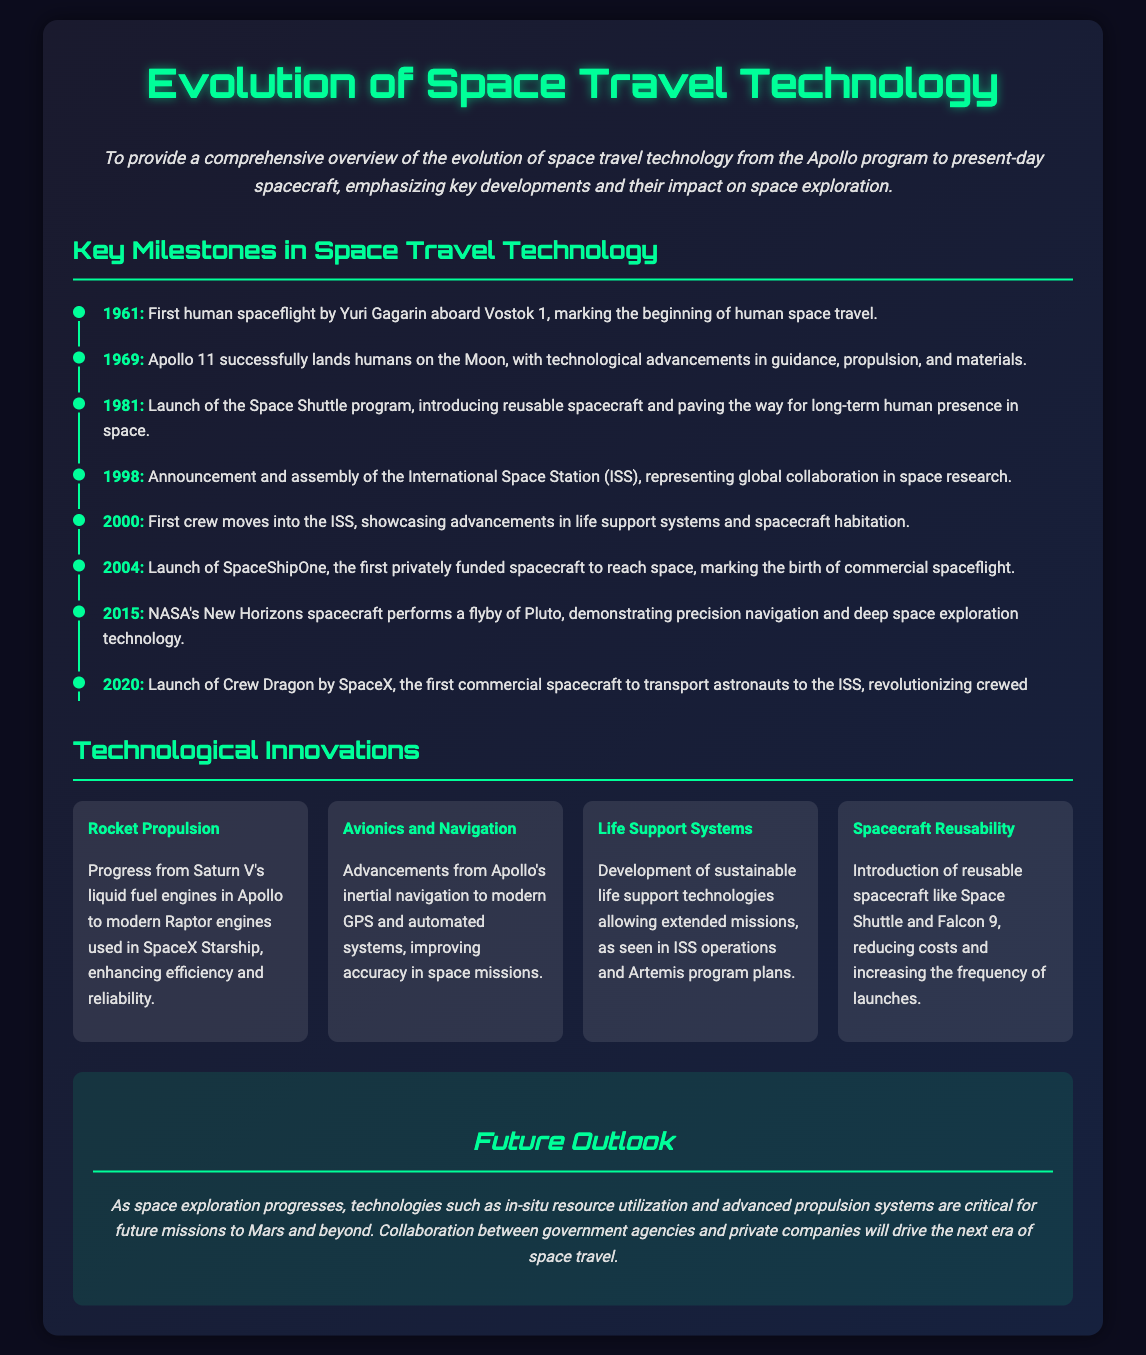What year did Apollo 11 land on the Moon? Apollo 11 successfully landed on the Moon in 1969, marking a pivotal moment in space exploration.
Answer: 1969 Who was the first human to travel into space? The document states that Yuri Gagarin was the first human to travel into space aboard Vostok 1 in 1961.
Answer: Yuri Gagarin What spacecraft did SpaceX launch in 2020? SpaceX launched Crew Dragon in 2020, which was significant for transporting astronauts to the ISS.
Answer: Crew Dragon What innovation involves developing technologies for sustainable missions? The document discusses advancements in life support systems that allow for extended missions, particularly in the context of the ISS and Artemis program.
Answer: Life Support Systems What describes the collaboration represented by the ISS? The International Space Station (ISS) exemplifies global collaboration in space research, as mentioned when discussing its announcement and assembly in 1998.
Answer: Global collaboration 